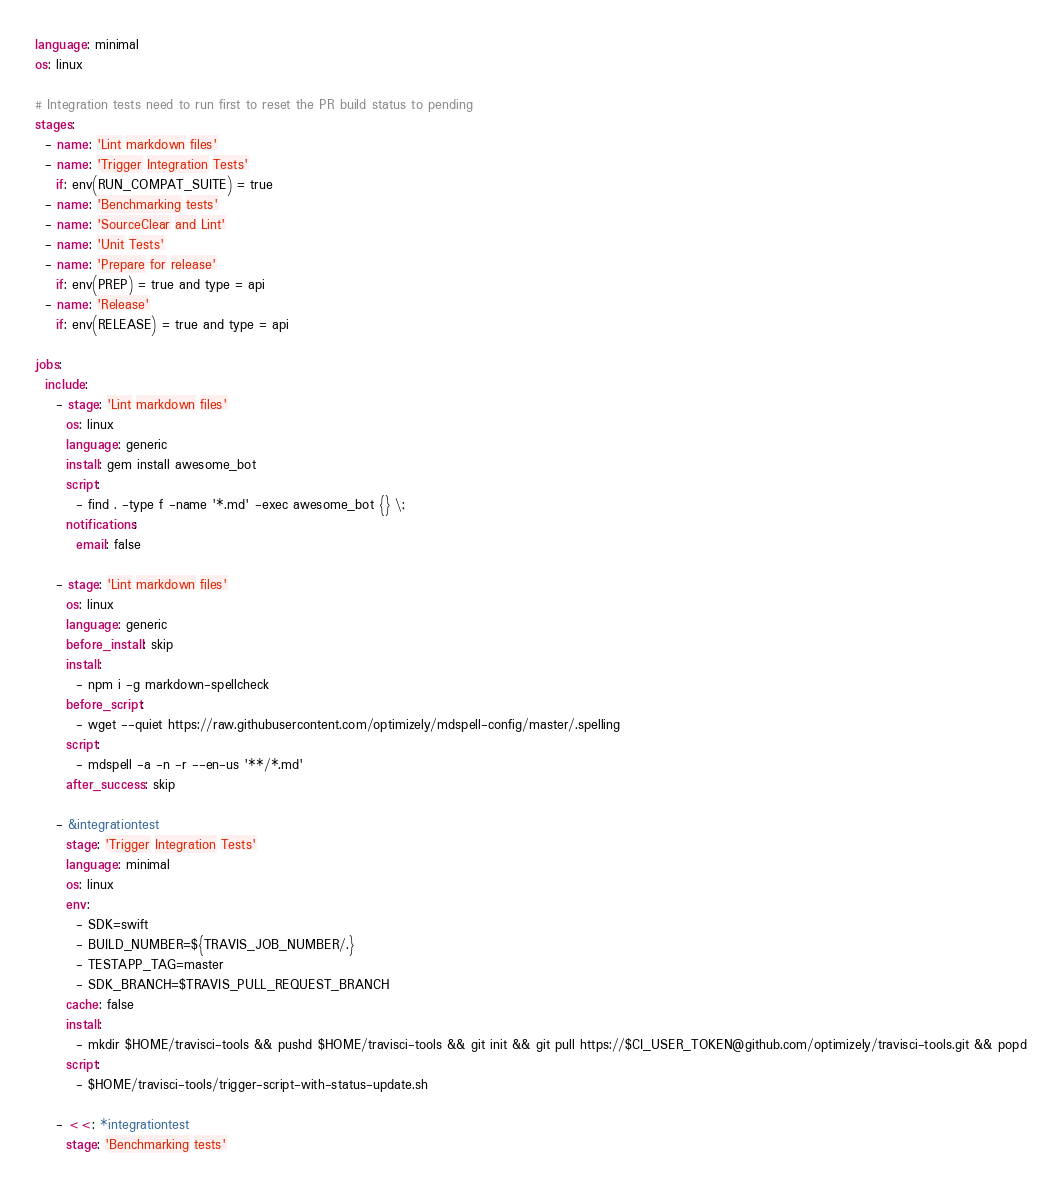<code> <loc_0><loc_0><loc_500><loc_500><_YAML_>language: minimal
os: linux

# Integration tests need to run first to reset the PR build status to pending
stages:
  - name: 'Lint markdown files'
  - name: 'Trigger Integration Tests'
    if: env(RUN_COMPAT_SUITE) = true
  - name: 'Benchmarking tests'
  - name: 'SourceClear and Lint'
  - name: 'Unit Tests'
  - name: 'Prepare for release'
    if: env(PREP) = true and type = api
  - name: 'Release'
    if: env(RELEASE) = true and type = api

jobs:
  include:
    - stage: 'Lint markdown files'
      os: linux
      language: generic
      install: gem install awesome_bot
      script:
        - find . -type f -name '*.md' -exec awesome_bot {} \;
      notifications:
        email: false

    - stage: 'Lint markdown files'
      os: linux
      language: generic
      before_install: skip
      install:
        - npm i -g markdown-spellcheck
      before_script:
        - wget --quiet https://raw.githubusercontent.com/optimizely/mdspell-config/master/.spelling
      script:
        - mdspell -a -n -r --en-us '**/*.md'
      after_success: skip

    - &integrationtest
      stage: 'Trigger Integration Tests'
      language: minimal
      os: linux
      env:
        - SDK=swift
        - BUILD_NUMBER=${TRAVIS_JOB_NUMBER/.}
        - TESTAPP_TAG=master
        - SDK_BRANCH=$TRAVIS_PULL_REQUEST_BRANCH
      cache: false
      install:
        - mkdir $HOME/travisci-tools && pushd $HOME/travisci-tools && git init && git pull https://$CI_USER_TOKEN@github.com/optimizely/travisci-tools.git && popd
      script:
        - $HOME/travisci-tools/trigger-script-with-status-update.sh
    
    - <<: *integrationtest
      stage: 'Benchmarking tests'</code> 